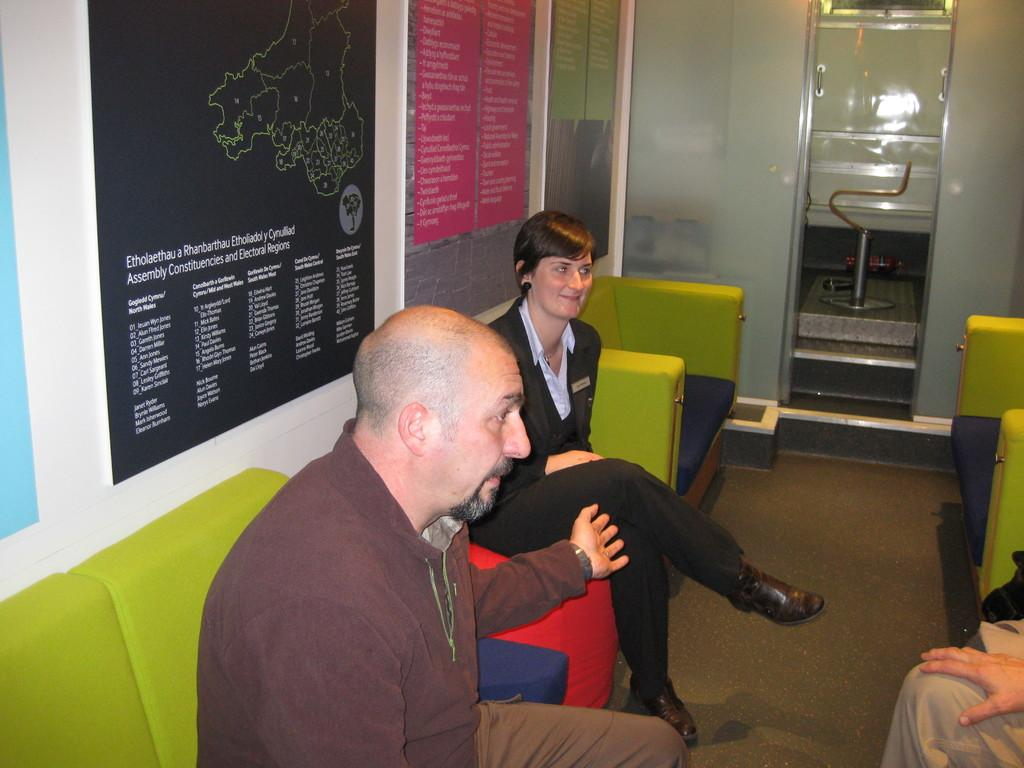<image>
Describe the image concisely. People talking in a room with a poster behind them that says ASSEMBLY on it. 